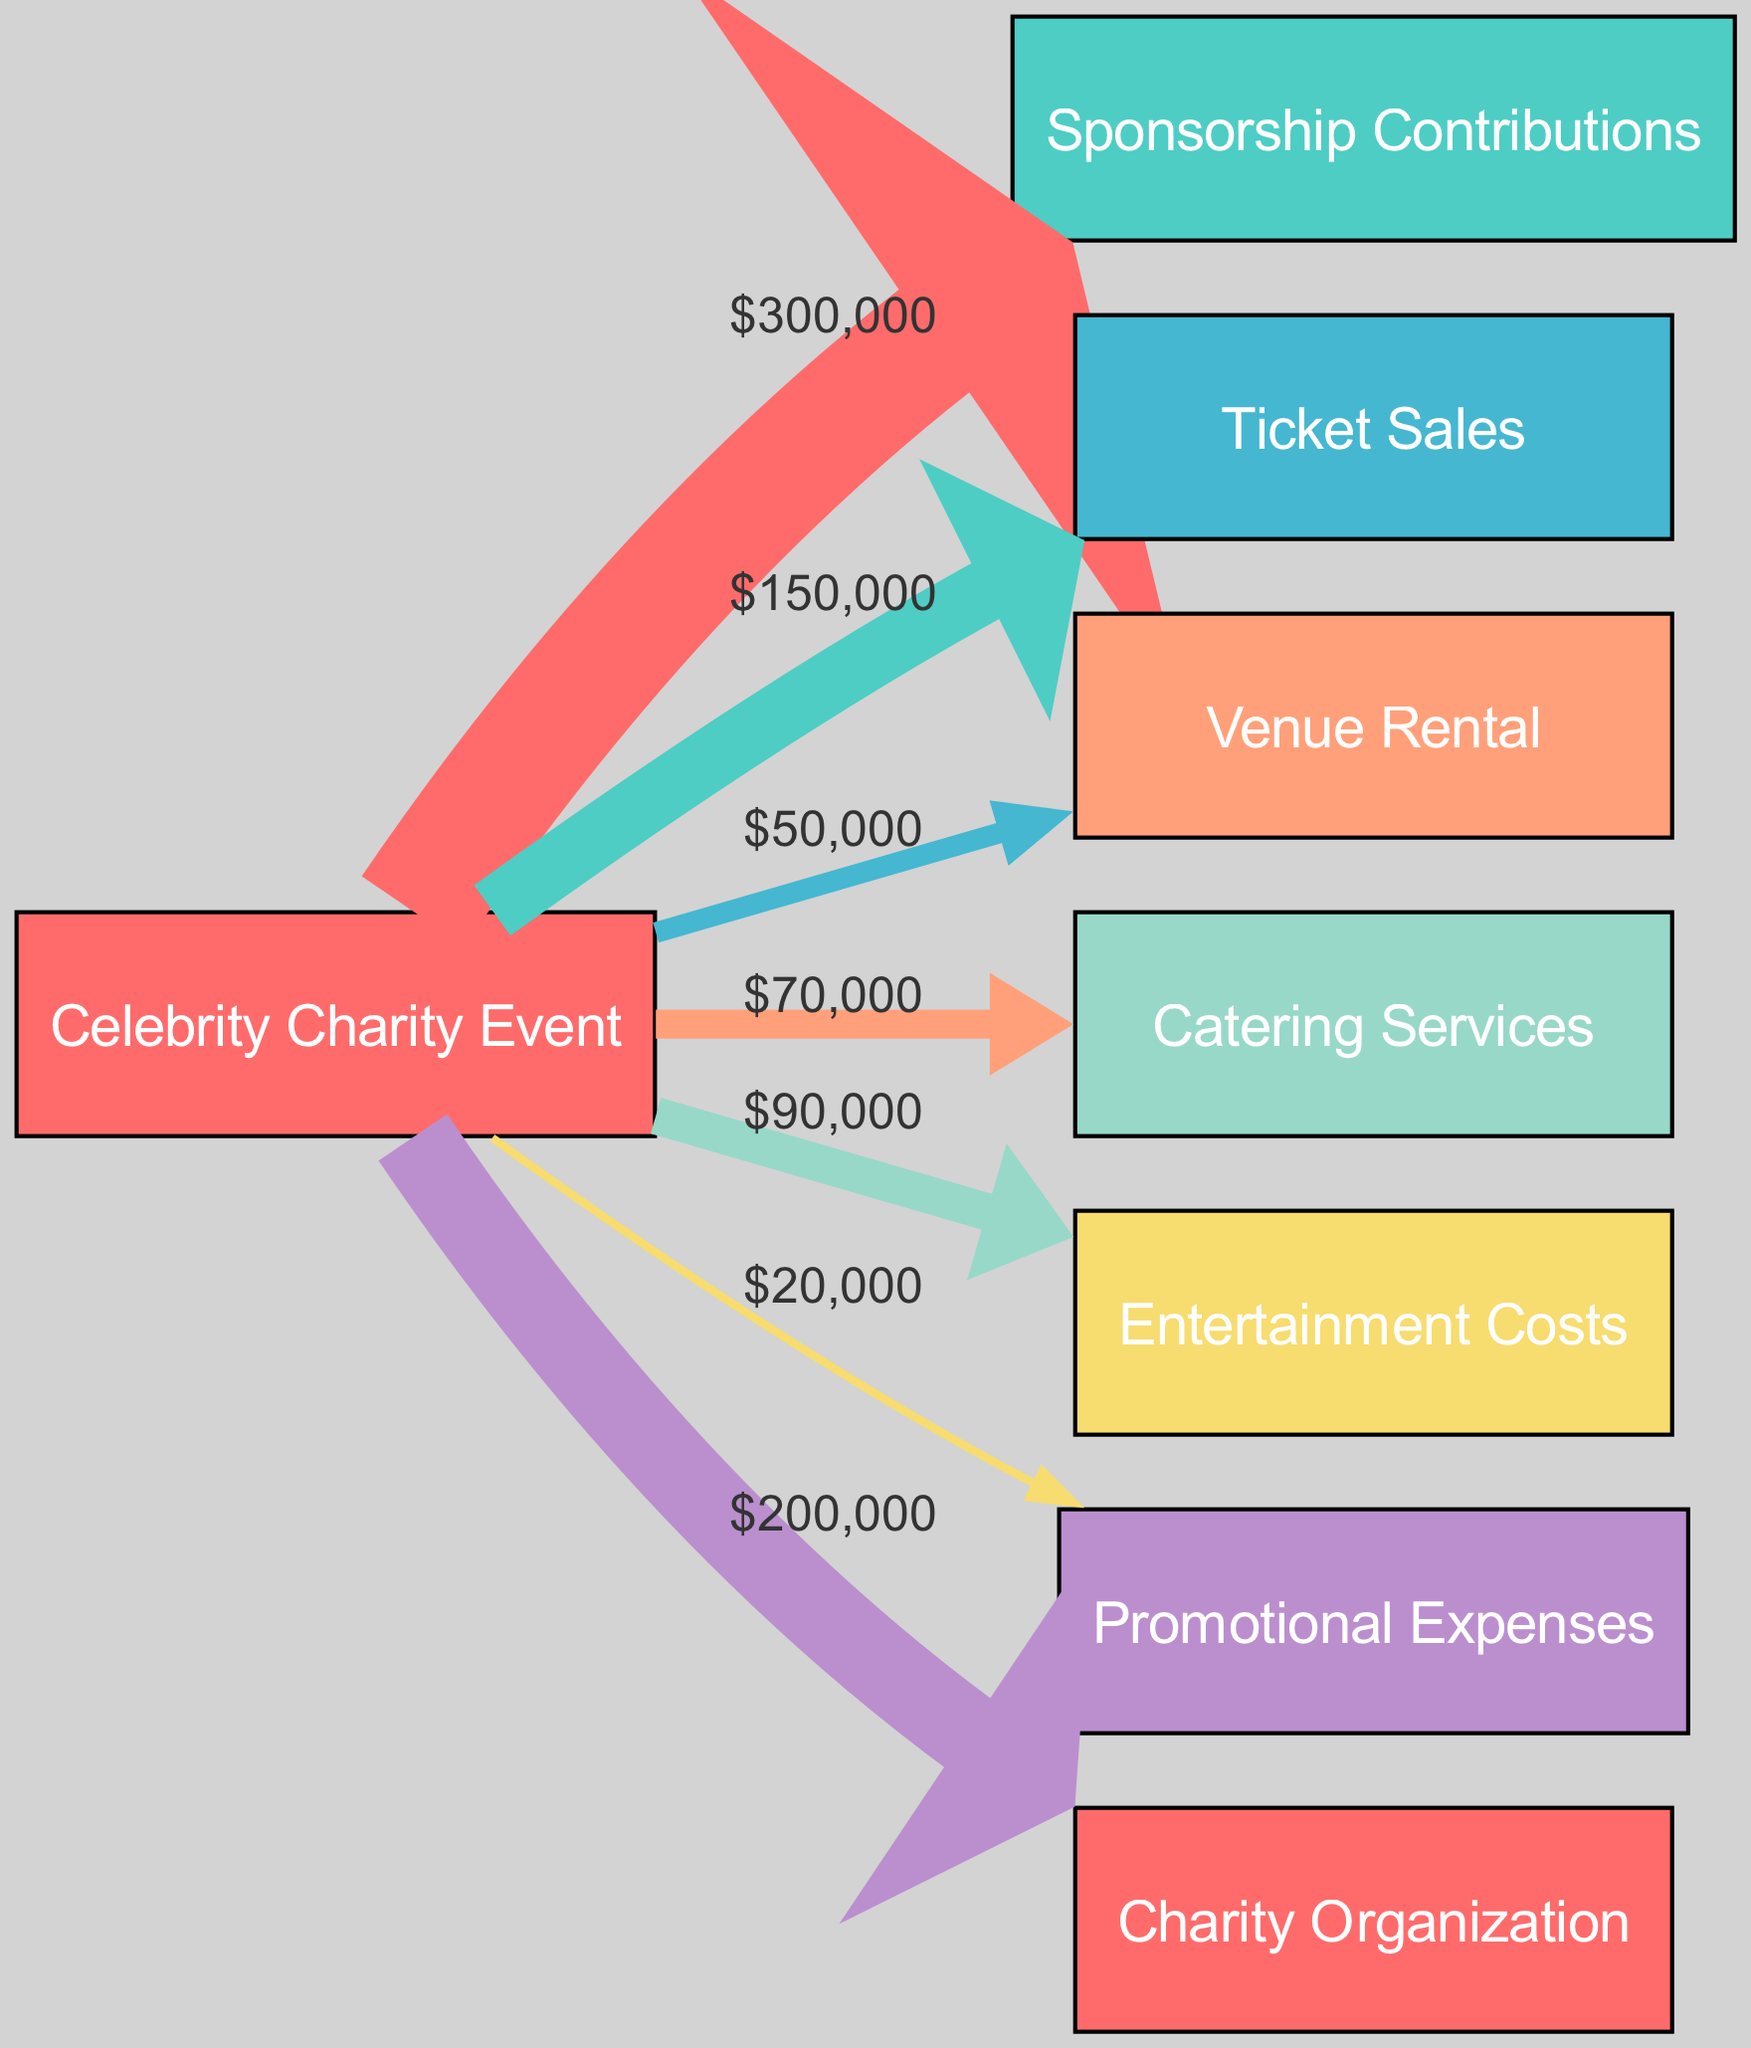What is the total funding from sponsorship contributions? The diagram shows a direct connection from the "Celebrity Charity Event" to "Sponsorship Contributions," with a value of 300,000. Thus, the total funding from sponsorship contributions is simply the value indicated along that connection.
Answer: 300,000 How much money was raised through ticket sales? The value flowing from "Celebrity Charity Event" to "Ticket Sales" is marked as 150,000. This indicates the total amount raised from ticket sales for the event.
Answer: 150,000 What is the cost of venue rental? In the diagram, the connection from "Celebrity Charity Event" to "Venue Rental" has a value of 50,000. This directly represents the expense incurred for venue rental.
Answer: 50,000 Which category has the highest expense? To determine the highest expense, we can compare the values of all the outgoing links from the "Celebrity Charity Event." The maximum value is found in "Entertainment Costs" with a value of 90,000, which is greater than the other expenses.
Answer: Entertainment Costs What percentage of total funding goes to the charity organization? First, calculate the total funding from sponsorship contributions (300,000) and ticket sales (150,000), resulting in 450,000. The contribution to the charity organization is 200,000. To find the percentage, divide 200,000 by 450,000 and multiply by 100, resulting in approximately 44.44%.
Answer: 44.44% What is the combined total of promotional expenses and catering services? From the diagram, "Promotional Expenses" is valued at 20,000, and "Catering Services" is valued at 70,000. By adding these two amounts together (20,000 + 70,000), we find the combined total of 90,000.
Answer: 90,000 How many total nodes are represented in the diagram? The diagram lists a total of eight unique nodes representing different aspects of the charity event, as shown in the "nodes" section described in the data structure.
Answer: 8 What portion of the total income comes from ticket sales? The total income consists of the total of sponsorship contributions (300,000) and ticket sales (150,000), amounting to 450,000. The portion from ticket sales can be found by dividing 150,000 by 450,000 and multiplying by 100, resulting in roughly 33.33%.
Answer: 33.33% Which expense has the lowest value? Analyzing the outgoing edges, we can see that "Promotional Expenses" has the lowest value at 20,000, which makes it the least expensive category among the listed expenses.
Answer: Promotional Expenses 